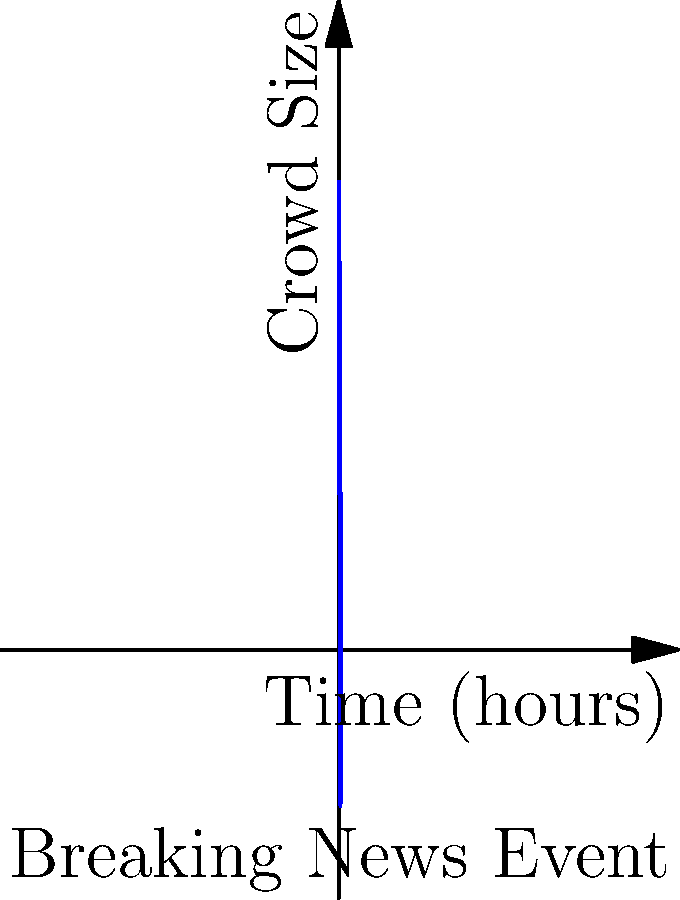During a major breaking news event, the crowd size at the scene changes over time as shown in the graph. At what time (in hours) does the crowd size increase at the fastest rate? Explain the significance of this moment for a reporter covering the event. To find when the crowd size increases at the fastest rate, we need to determine the maximum of the derivative of the function. Given the graph:

1. The function appears to be of the form $f(t) = A + B \sin(\frac{\pi t}{4})$, where $A$ is the vertical shift and $B$ is the amplitude.

2. The derivative of this function is $f'(t) = \frac{\pi B}{4} \cos(\frac{\pi t}{4})$.

3. The maximum of $f'(t)$ occurs when $\cos(\frac{\pi t}{4}) = 1$, which happens when $\frac{\pi t}{4} = 0$ (or multiples of $2\pi$).

4. Solving for $t$: $t = 0$ (within the given domain of 0 to 8 hours).

5. This means the crowd size increases most rapidly at the very beginning of the event (t = 0 hours).

For a reporter, this moment is crucial as it represents the initial surge of interest in the breaking news. It's when the story is freshest and the public's attention is at its peak, making it an ideal time for live reporting and capturing the immediate reactions of those arriving at the scene.
Answer: 0 hours 